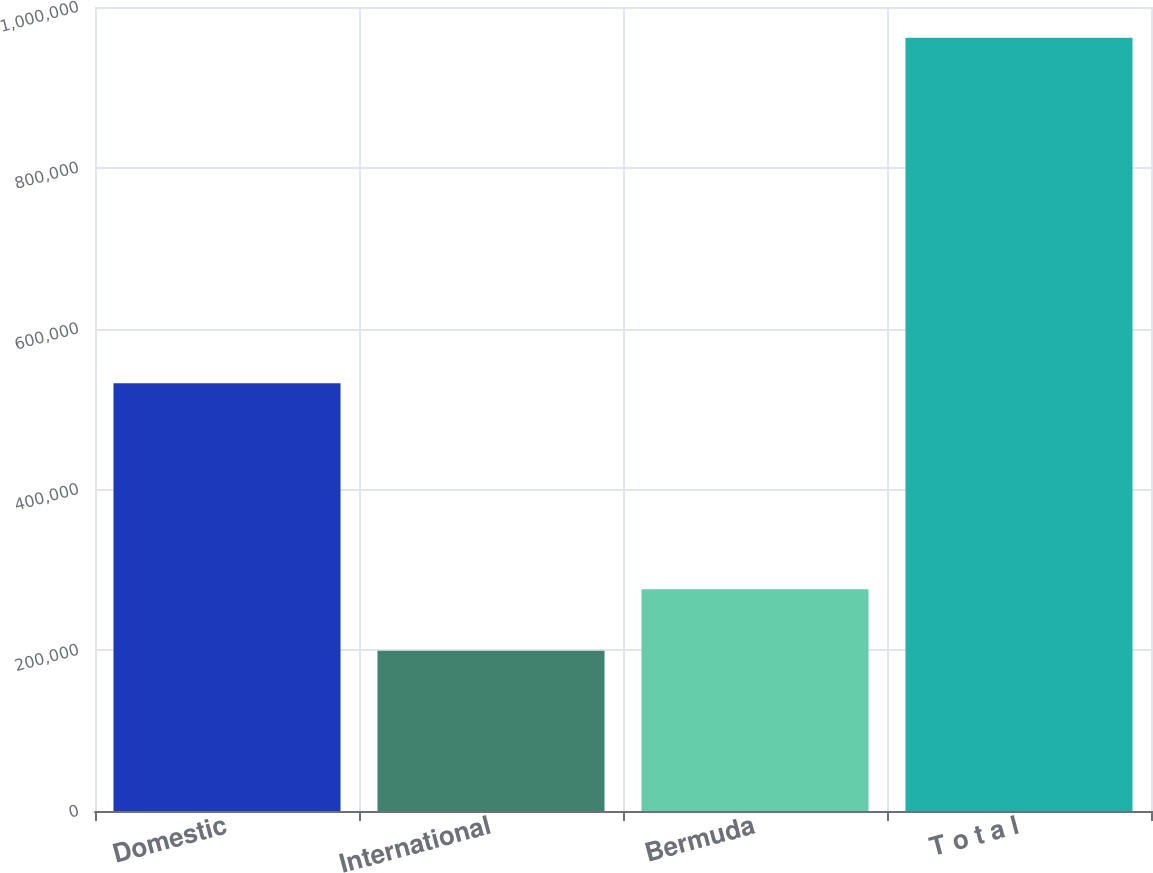Convert chart to OTSL. <chart><loc_0><loc_0><loc_500><loc_500><bar_chart><fcel>Domestic<fcel>International<fcel>Bermuda<fcel>T o t a l<nl><fcel>531946<fcel>199460<fcel>275693<fcel>961788<nl></chart> 